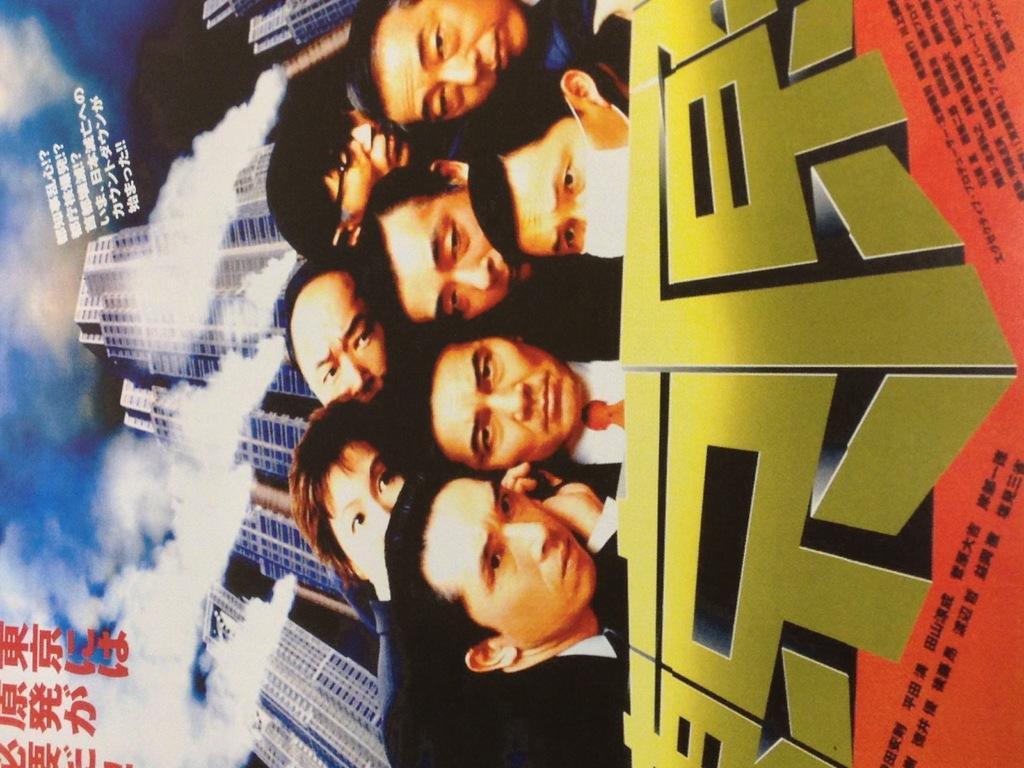Describe this image in one or two sentences. In this picture we can see a poster, here we can see people and buildings and we can see sky in the background, here we can see some text on it. 